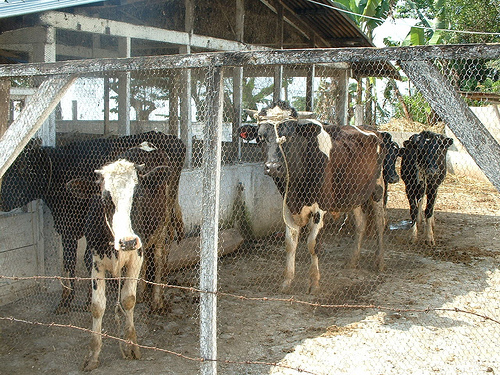Are there any signs that indicate what time of day it could be? Based on the image, there are no definitive shadows or positioning of the sun that would clearly indicate the time of day. However, the lighting appears soft and not overly harsh, which might suggest it's either morning or late afternoon. The lack of strong shadow contrasts typically associated with midday sun further supports this estimation. 